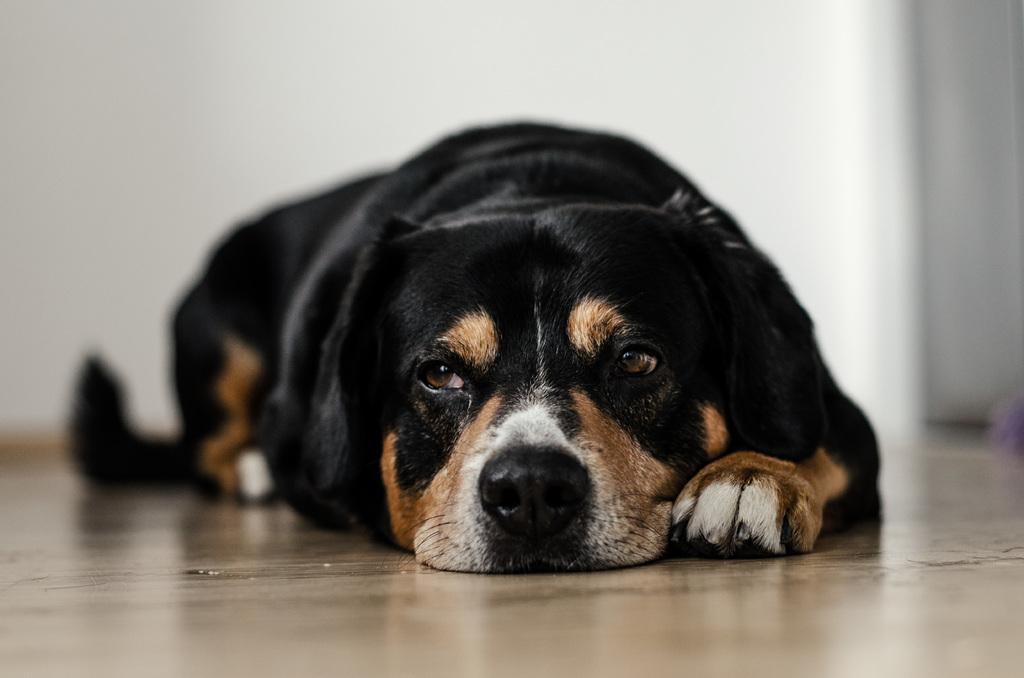In one or two sentences, can you explain what this image depicts? In this image we can see a dog on the floor and in the background, we can see the wall. 